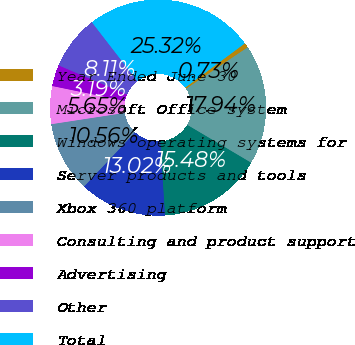Convert chart. <chart><loc_0><loc_0><loc_500><loc_500><pie_chart><fcel>Year Ended June 30<fcel>Microsoft Office system<fcel>Windows operating systems for<fcel>Server products and tools<fcel>Xbox 360 platform<fcel>Consulting and product support<fcel>Advertising<fcel>Other<fcel>Total<nl><fcel>0.73%<fcel>17.94%<fcel>15.48%<fcel>13.02%<fcel>10.56%<fcel>5.65%<fcel>3.19%<fcel>8.11%<fcel>25.32%<nl></chart> 